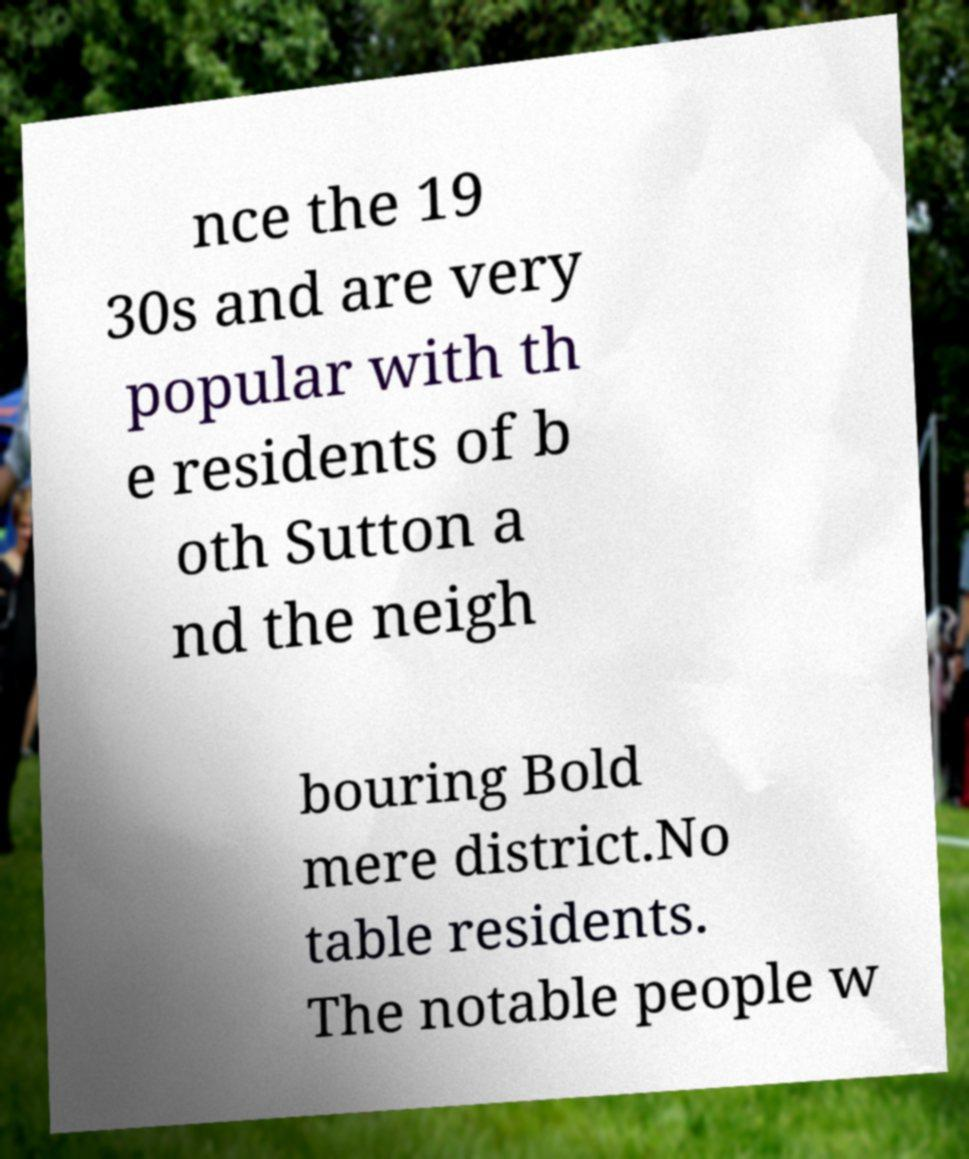For documentation purposes, I need the text within this image transcribed. Could you provide that? nce the 19 30s and are very popular with th e residents of b oth Sutton a nd the neigh bouring Bold mere district.No table residents. The notable people w 